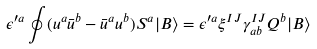<formula> <loc_0><loc_0><loc_500><loc_500>\epsilon ^ { \prime a } \oint ( u ^ { a } \bar { u } ^ { b } - \bar { u } ^ { a } u ^ { b } ) S ^ { a } | B \rangle = \epsilon ^ { \prime a } \xi ^ { I J } \gamma ^ { I J } _ { a b } Q ^ { b } | B \rangle</formula> 